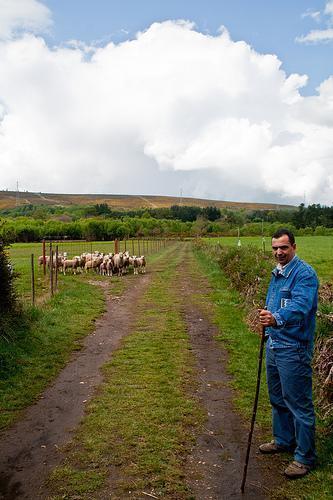How many men?
Give a very brief answer. 1. How many sheep are flying near a person?
Give a very brief answer. 0. 